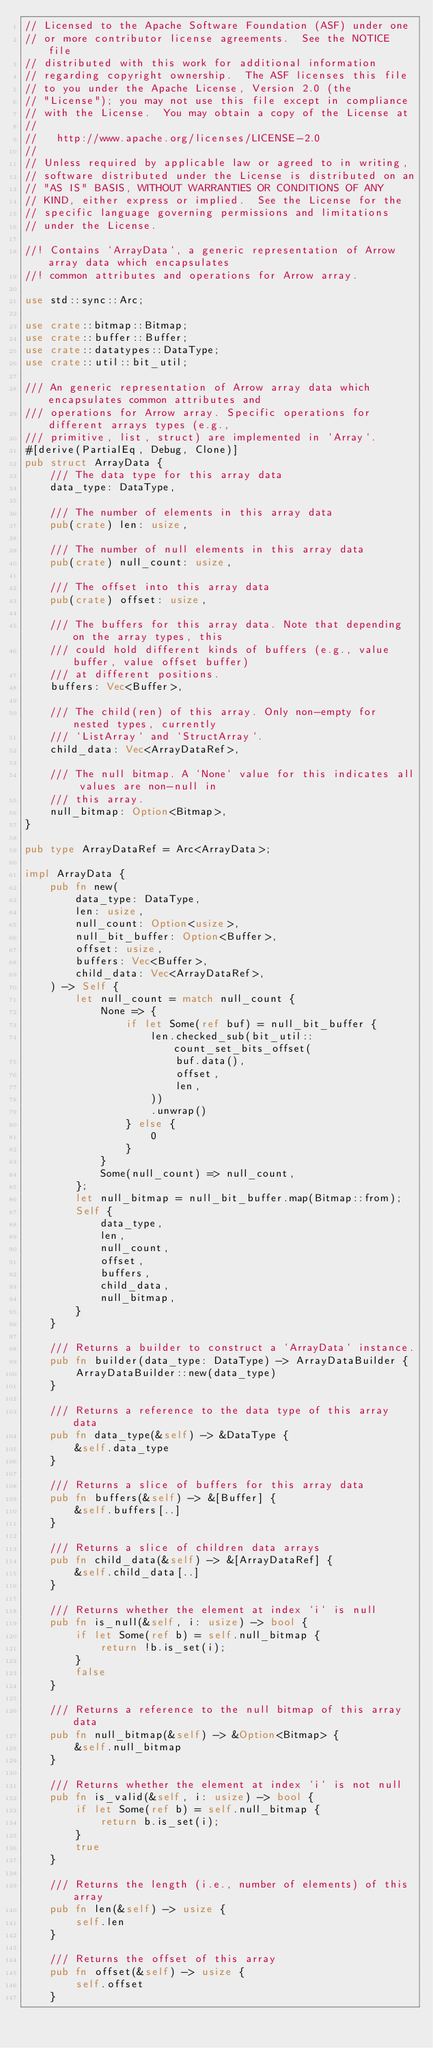Convert code to text. <code><loc_0><loc_0><loc_500><loc_500><_Rust_>// Licensed to the Apache Software Foundation (ASF) under one
// or more contributor license agreements.  See the NOTICE file
// distributed with this work for additional information
// regarding copyright ownership.  The ASF licenses this file
// to you under the Apache License, Version 2.0 (the
// "License"); you may not use this file except in compliance
// with the License.  You may obtain a copy of the License at
//
//   http://www.apache.org/licenses/LICENSE-2.0
//
// Unless required by applicable law or agreed to in writing,
// software distributed under the License is distributed on an
// "AS IS" BASIS, WITHOUT WARRANTIES OR CONDITIONS OF ANY
// KIND, either express or implied.  See the License for the
// specific language governing permissions and limitations
// under the License.

//! Contains `ArrayData`, a generic representation of Arrow array data which encapsulates
//! common attributes and operations for Arrow array.

use std::sync::Arc;

use crate::bitmap::Bitmap;
use crate::buffer::Buffer;
use crate::datatypes::DataType;
use crate::util::bit_util;

/// An generic representation of Arrow array data which encapsulates common attributes and
/// operations for Arrow array. Specific operations for different arrays types (e.g.,
/// primitive, list, struct) are implemented in `Array`.
#[derive(PartialEq, Debug, Clone)]
pub struct ArrayData {
    /// The data type for this array data
    data_type: DataType,

    /// The number of elements in this array data
    pub(crate) len: usize,

    /// The number of null elements in this array data
    pub(crate) null_count: usize,

    /// The offset into this array data
    pub(crate) offset: usize,

    /// The buffers for this array data. Note that depending on the array types, this
    /// could hold different kinds of buffers (e.g., value buffer, value offset buffer)
    /// at different positions.
    buffers: Vec<Buffer>,

    /// The child(ren) of this array. Only non-empty for nested types, currently
    /// `ListArray` and `StructArray`.
    child_data: Vec<ArrayDataRef>,

    /// The null bitmap. A `None` value for this indicates all values are non-null in
    /// this array.
    null_bitmap: Option<Bitmap>,
}

pub type ArrayDataRef = Arc<ArrayData>;

impl ArrayData {
    pub fn new(
        data_type: DataType,
        len: usize,
        null_count: Option<usize>,
        null_bit_buffer: Option<Buffer>,
        offset: usize,
        buffers: Vec<Buffer>,
        child_data: Vec<ArrayDataRef>,
    ) -> Self {
        let null_count = match null_count {
            None => {
                if let Some(ref buf) = null_bit_buffer {
                    len.checked_sub(bit_util::count_set_bits_offset(
                        buf.data(),
                        offset,
                        len,
                    ))
                    .unwrap()
                } else {
                    0
                }
            }
            Some(null_count) => null_count,
        };
        let null_bitmap = null_bit_buffer.map(Bitmap::from);
        Self {
            data_type,
            len,
            null_count,
            offset,
            buffers,
            child_data,
            null_bitmap,
        }
    }

    /// Returns a builder to construct a `ArrayData` instance.
    pub fn builder(data_type: DataType) -> ArrayDataBuilder {
        ArrayDataBuilder::new(data_type)
    }

    /// Returns a reference to the data type of this array data
    pub fn data_type(&self) -> &DataType {
        &self.data_type
    }

    /// Returns a slice of buffers for this array data
    pub fn buffers(&self) -> &[Buffer] {
        &self.buffers[..]
    }

    /// Returns a slice of children data arrays
    pub fn child_data(&self) -> &[ArrayDataRef] {
        &self.child_data[..]
    }

    /// Returns whether the element at index `i` is null
    pub fn is_null(&self, i: usize) -> bool {
        if let Some(ref b) = self.null_bitmap {
            return !b.is_set(i);
        }
        false
    }

    /// Returns a reference to the null bitmap of this array data
    pub fn null_bitmap(&self) -> &Option<Bitmap> {
        &self.null_bitmap
    }

    /// Returns whether the element at index `i` is not null
    pub fn is_valid(&self, i: usize) -> bool {
        if let Some(ref b) = self.null_bitmap {
            return b.is_set(i);
        }
        true
    }

    /// Returns the length (i.e., number of elements) of this array
    pub fn len(&self) -> usize {
        self.len
    }

    /// Returns the offset of this array
    pub fn offset(&self) -> usize {
        self.offset
    }
</code> 